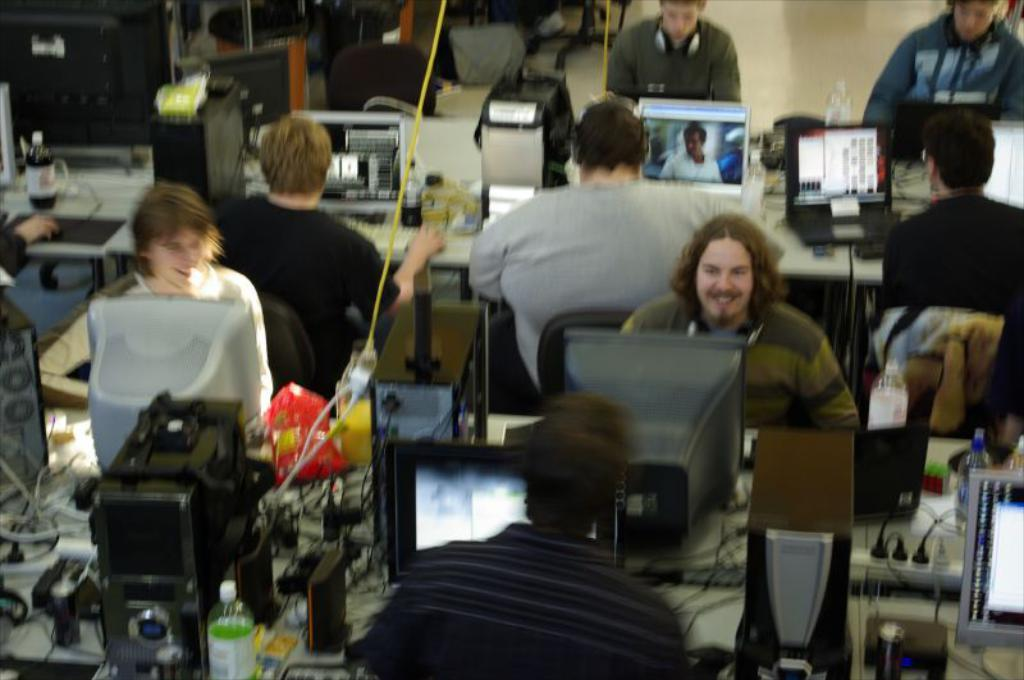What is happening in the image? There is a group of people in the image, and they are sitting. What are the people doing while sitting? The people are using systems, likely electronic devices or computers. How many pizzas are being served on the table in the image? There is no table or pizzas present in the image. What type of machine is being used by the people in the image? The image does not specify the type of system being used, so it is not possible to determine the exact nature of the machine. 